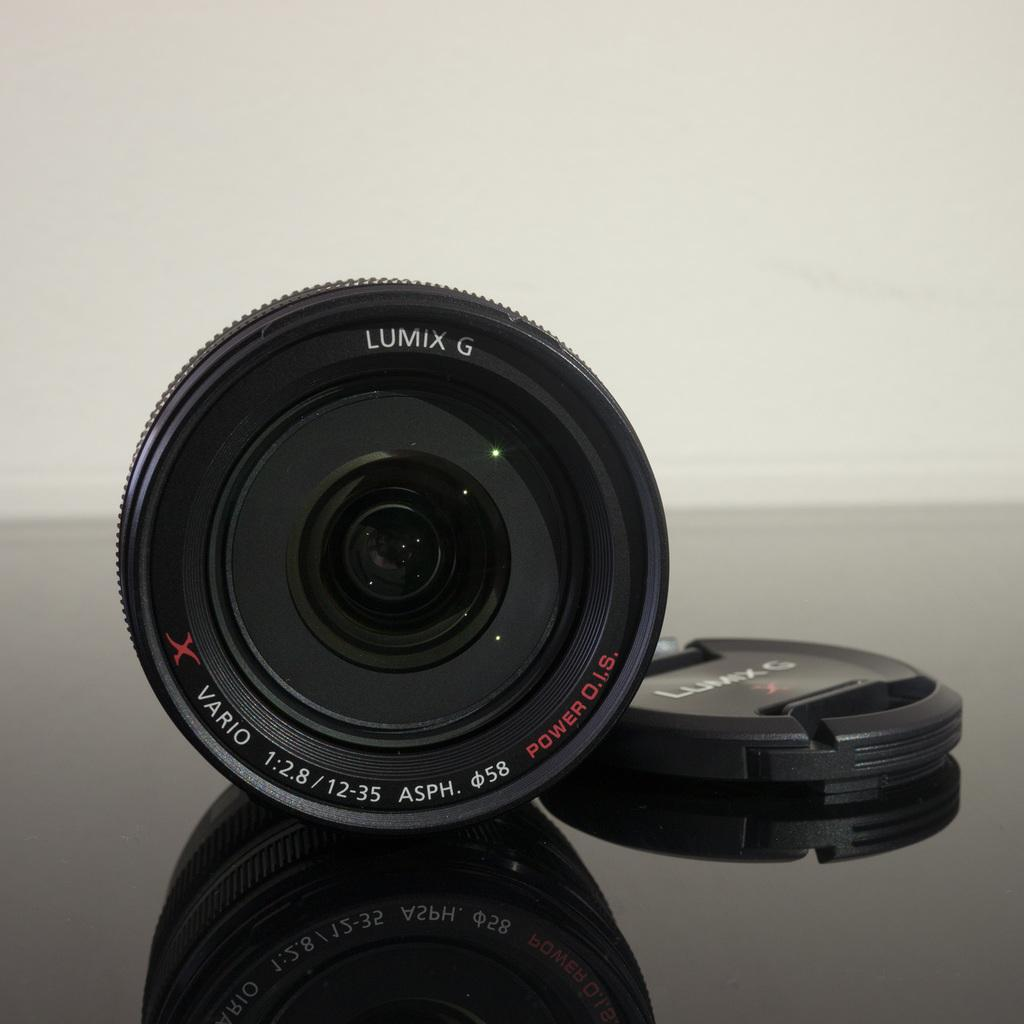What is the main subject of the image? The main subject of the image is a camera lens. What color is the surface on which the camera lens is placed? The camera lens is on a black surface. What can be seen behind the camera lens in the image? There is a white background visible in the image. What type of chalk is being used to write the title on the camera lens? There is no chalk or title present on the camera lens in the image. 